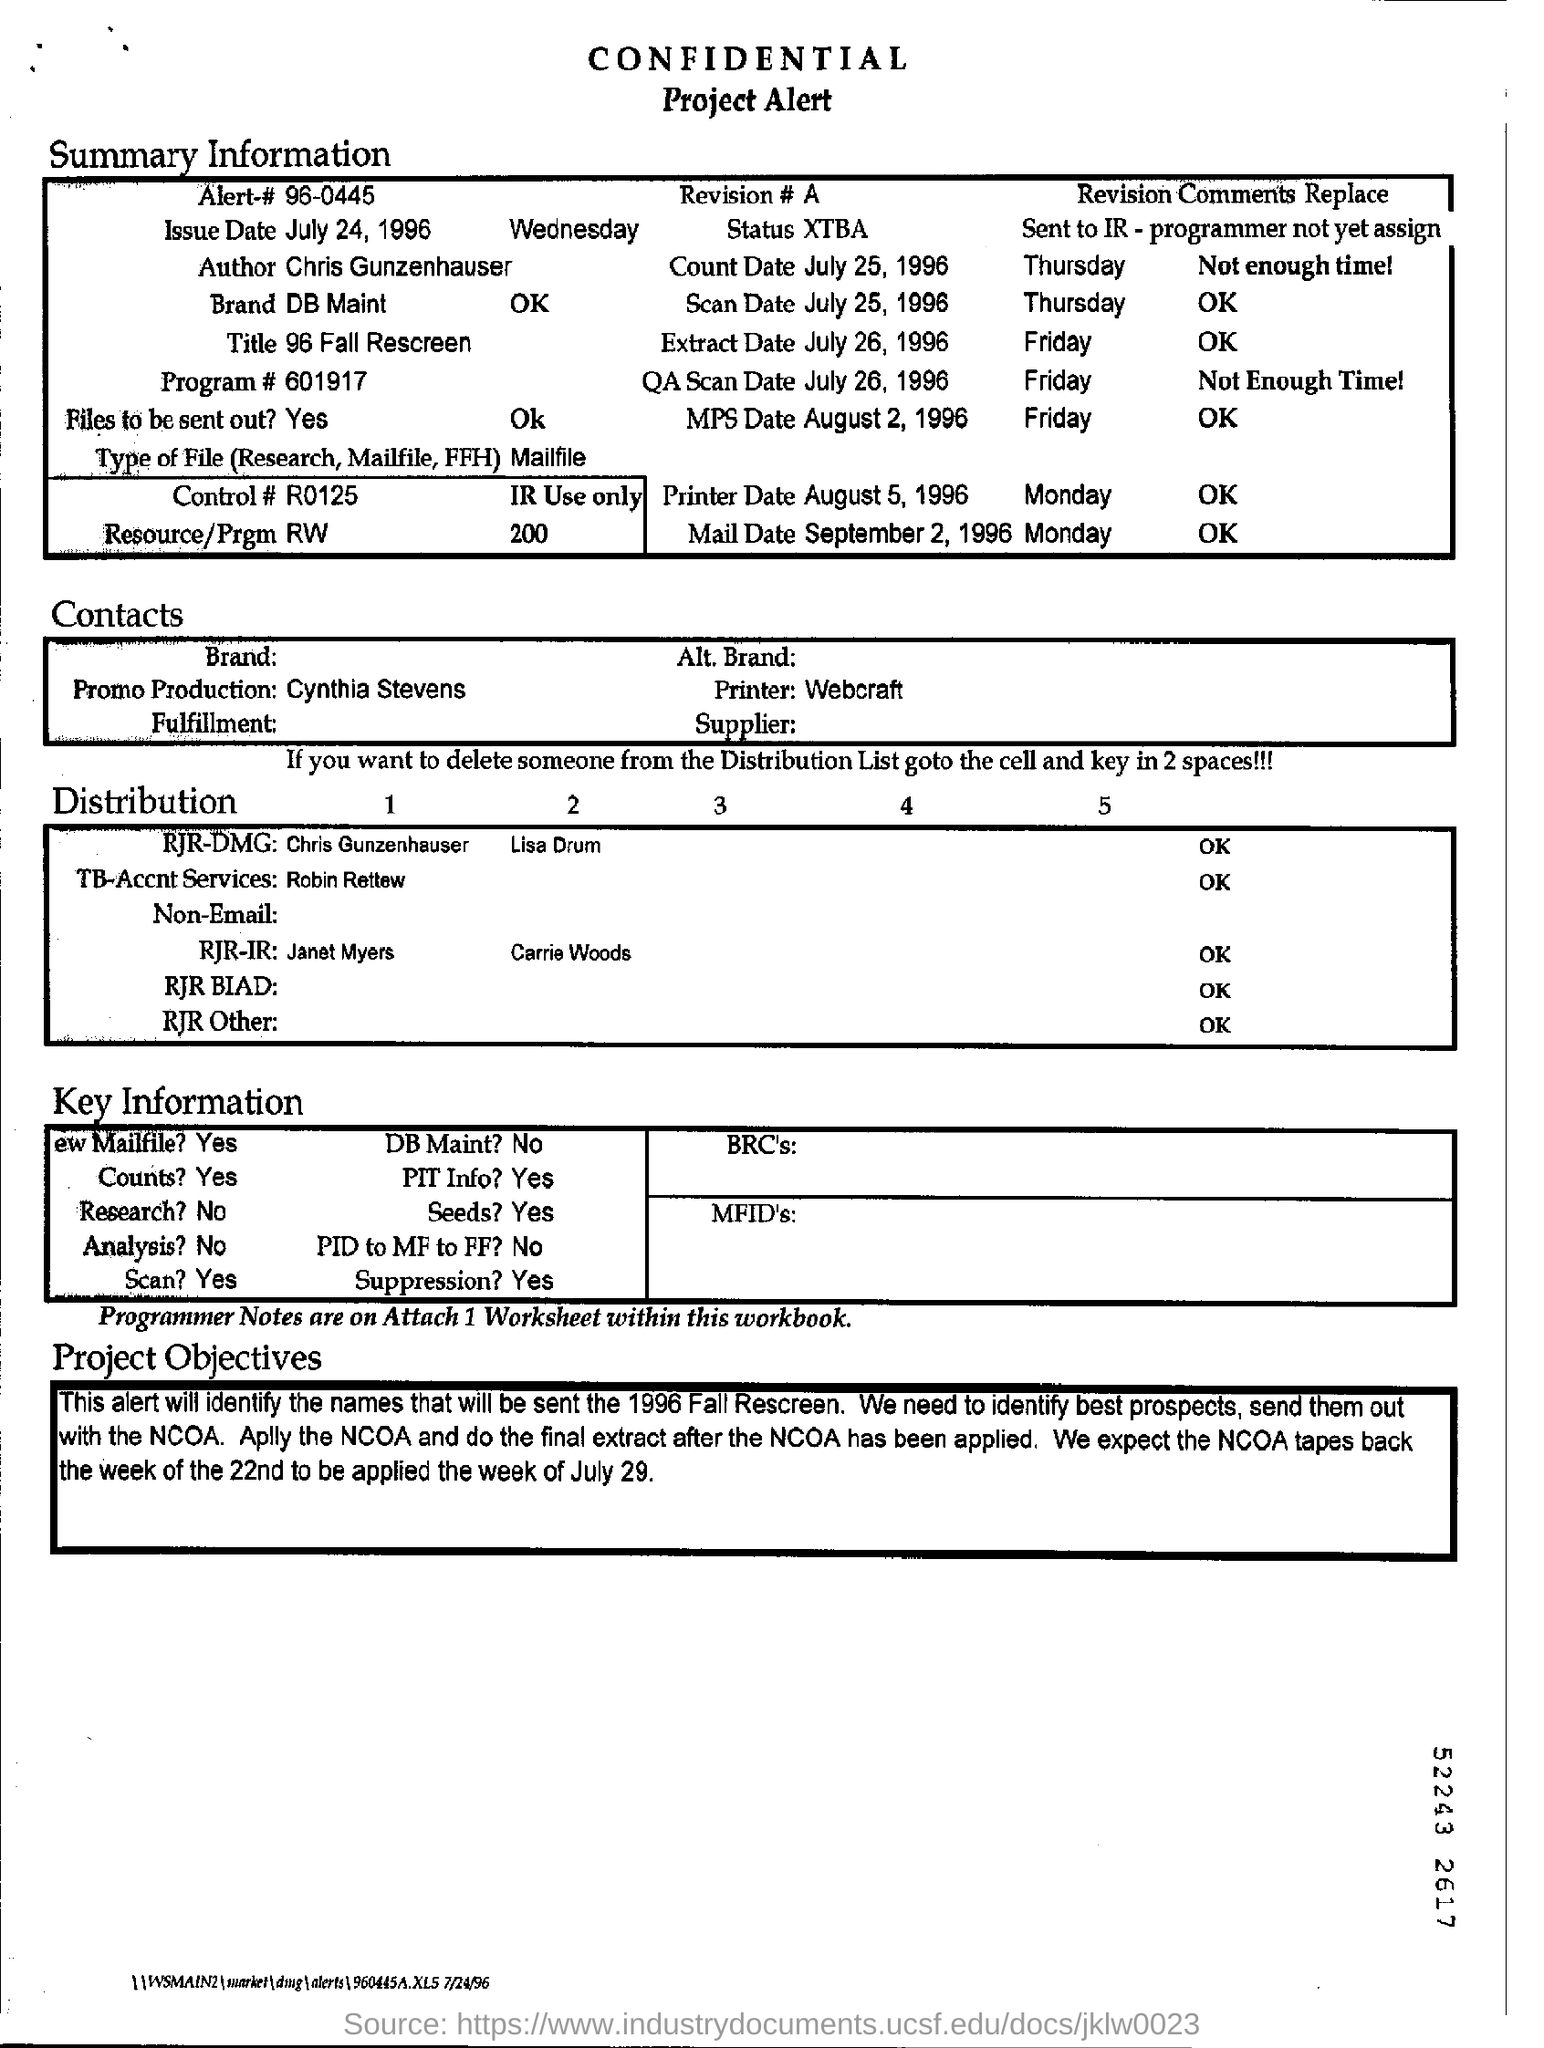Give some essential details in this illustration. The issue date of the project was July 24, 1996. The project is the work of Chris Gunzenhauser. 